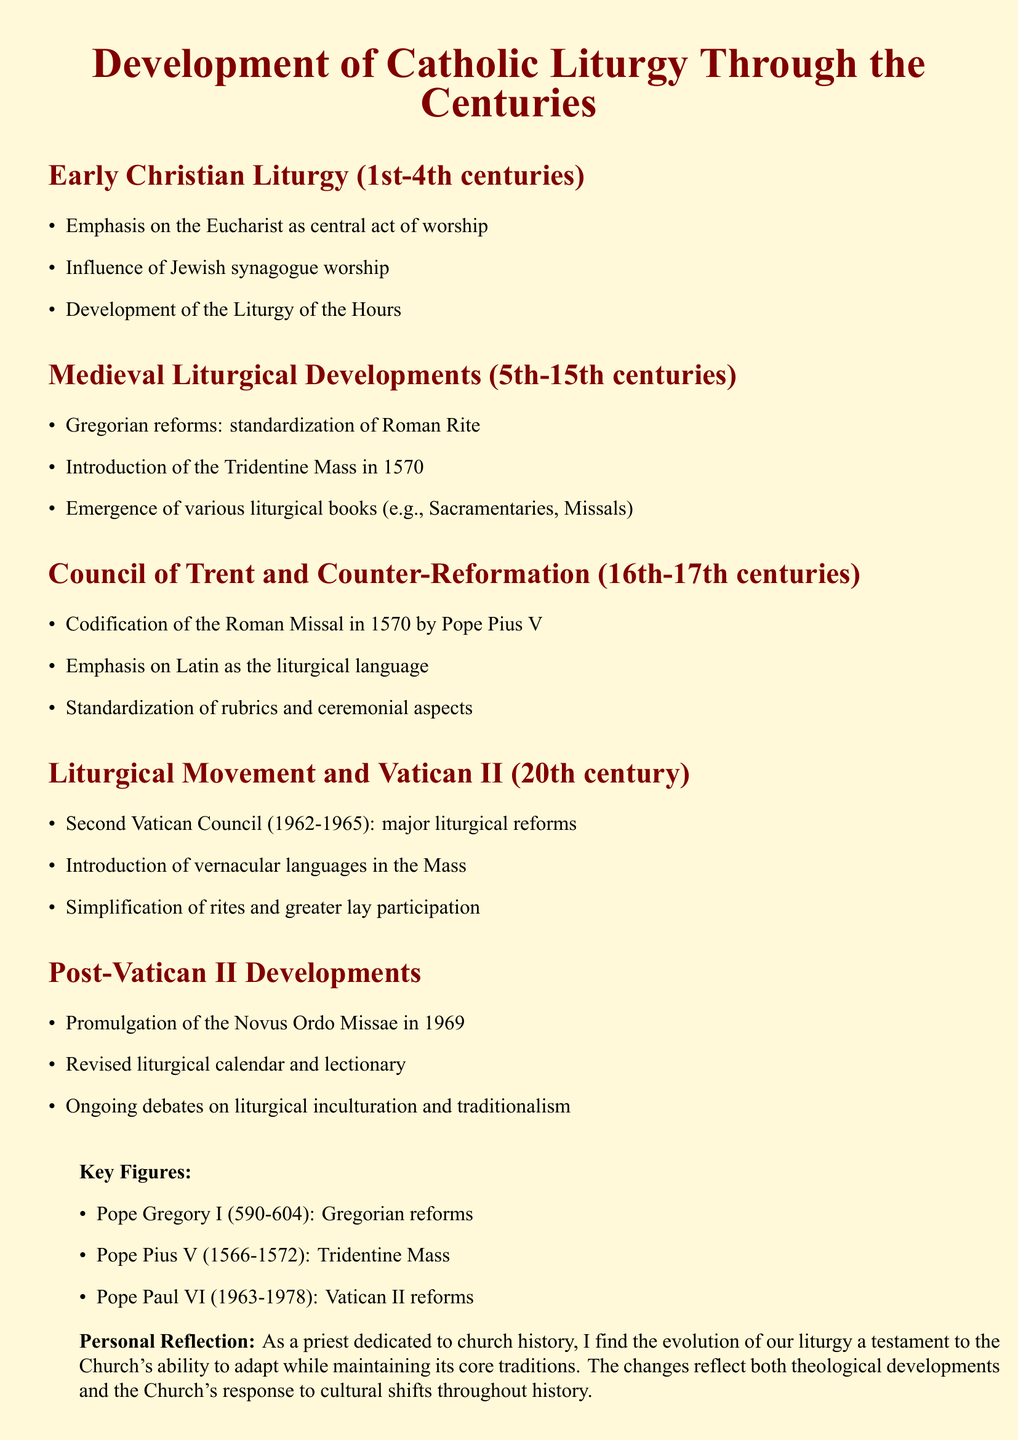What was the central act of worship in Early Christian Liturgy? The central act of worship was emphasized as the Eucharist.
Answer: Eucharist Who codified the Roman Missal and when? The Roman Missal was codified by Pope Pius V in 1570.
Answer: Pope Pius V, 1570 Which pope introduced the Tridentine Mass? The introduction of the Tridentine Mass was by Pope Pius V.
Answer: Pope Pius V What major reforms occurred during the Second Vatican Council? The Second Vatican Council saw major liturgical reforms including the introduction of vernacular languages in the Mass.
Answer: Vernacular languages in the Mass What year was the Novus Ordo Missae promulgated? The Novus Ordo Missae was promulgated in 1969.
Answer: 1969 Which centuries are referred to as the Medieval Liturgical Developments? Medieval Liturgical Developments spanned the 5th to the 15th centuries.
Answer: 5th-15th centuries What is one debate mentioned regarding Post-Vatican II developments? The ongoing debates include aspects of liturgical inculturation and traditionalism.
Answer: Liturgical inculturation and traditionalism How did the liturgical role of laypeople change after Vatican II? There was an increase in greater lay participation in the liturgy.
Answer: Greater lay participation 